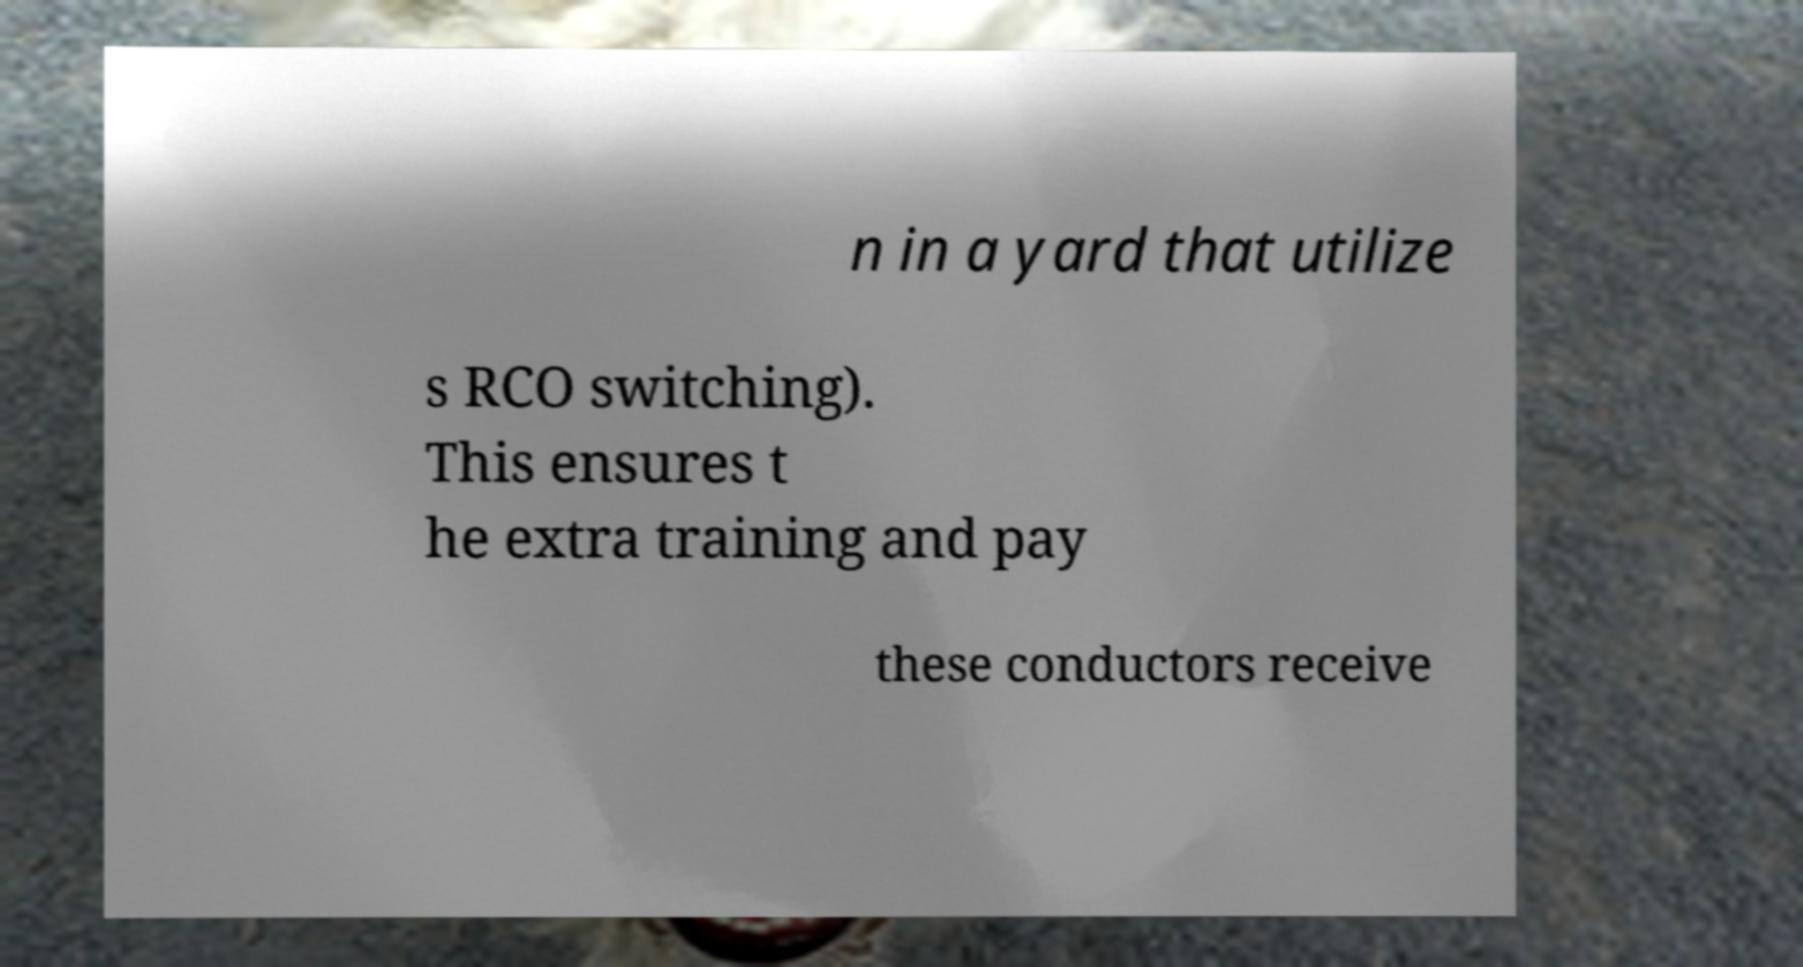Please identify and transcribe the text found in this image. n in a yard that utilize s RCO switching). This ensures t he extra training and pay these conductors receive 